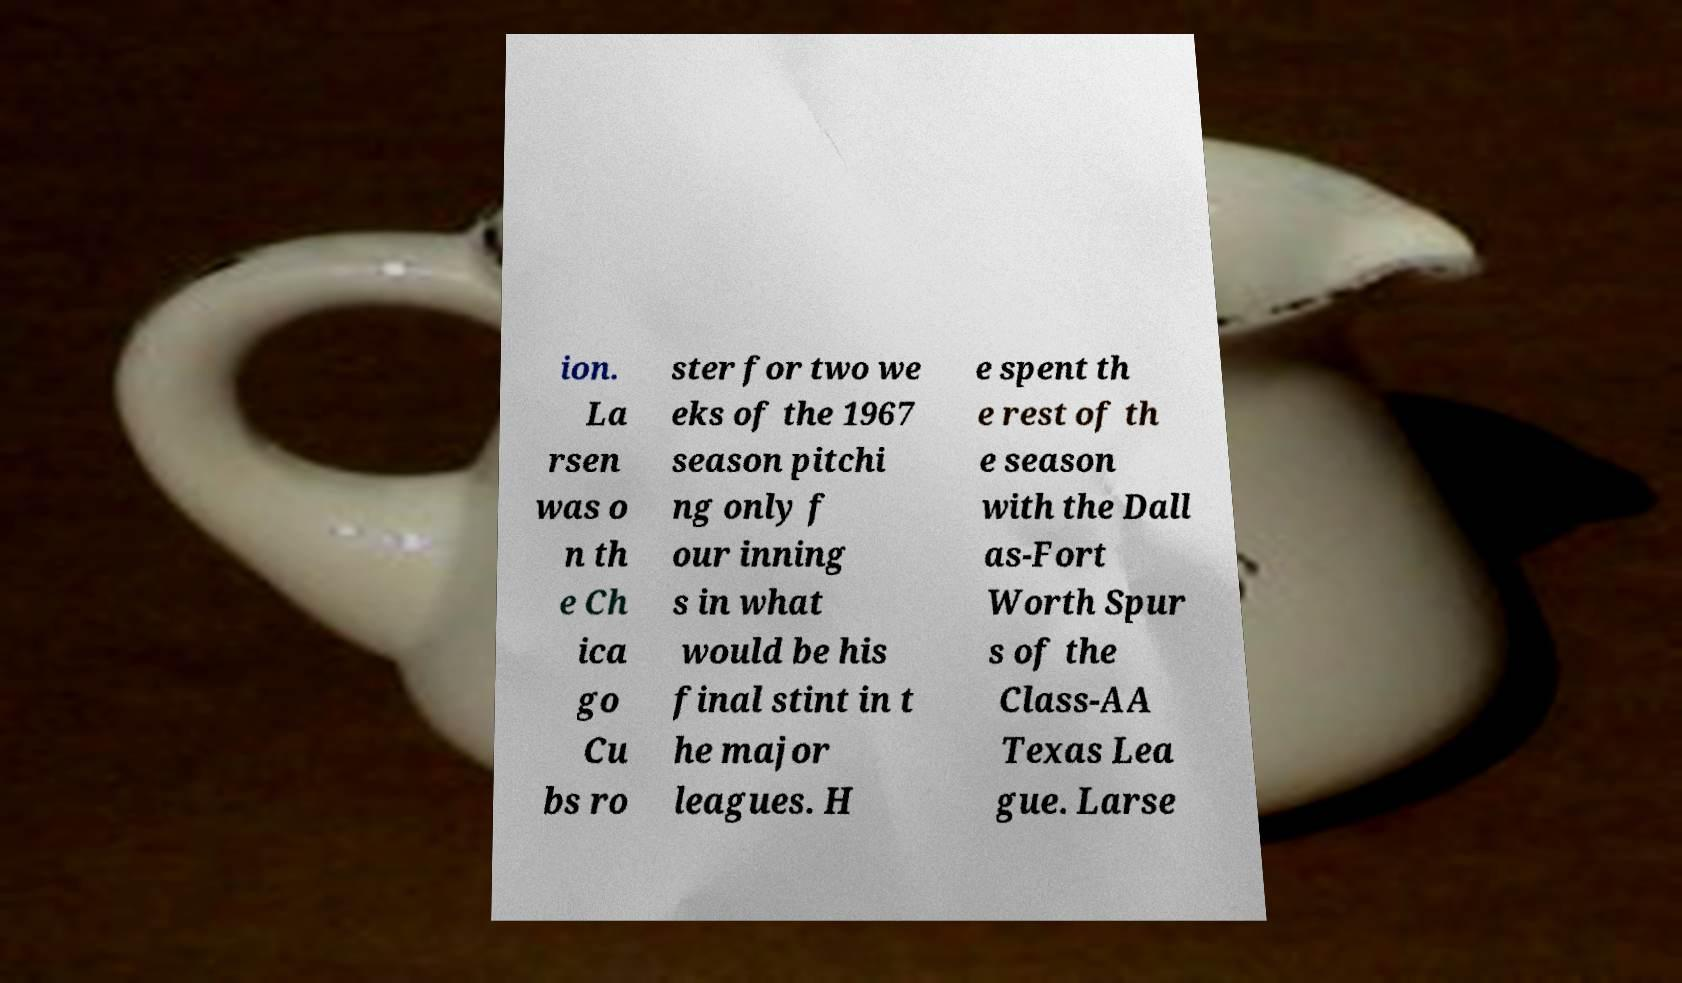For documentation purposes, I need the text within this image transcribed. Could you provide that? ion. La rsen was o n th e Ch ica go Cu bs ro ster for two we eks of the 1967 season pitchi ng only f our inning s in what would be his final stint in t he major leagues. H e spent th e rest of th e season with the Dall as-Fort Worth Spur s of the Class-AA Texas Lea gue. Larse 